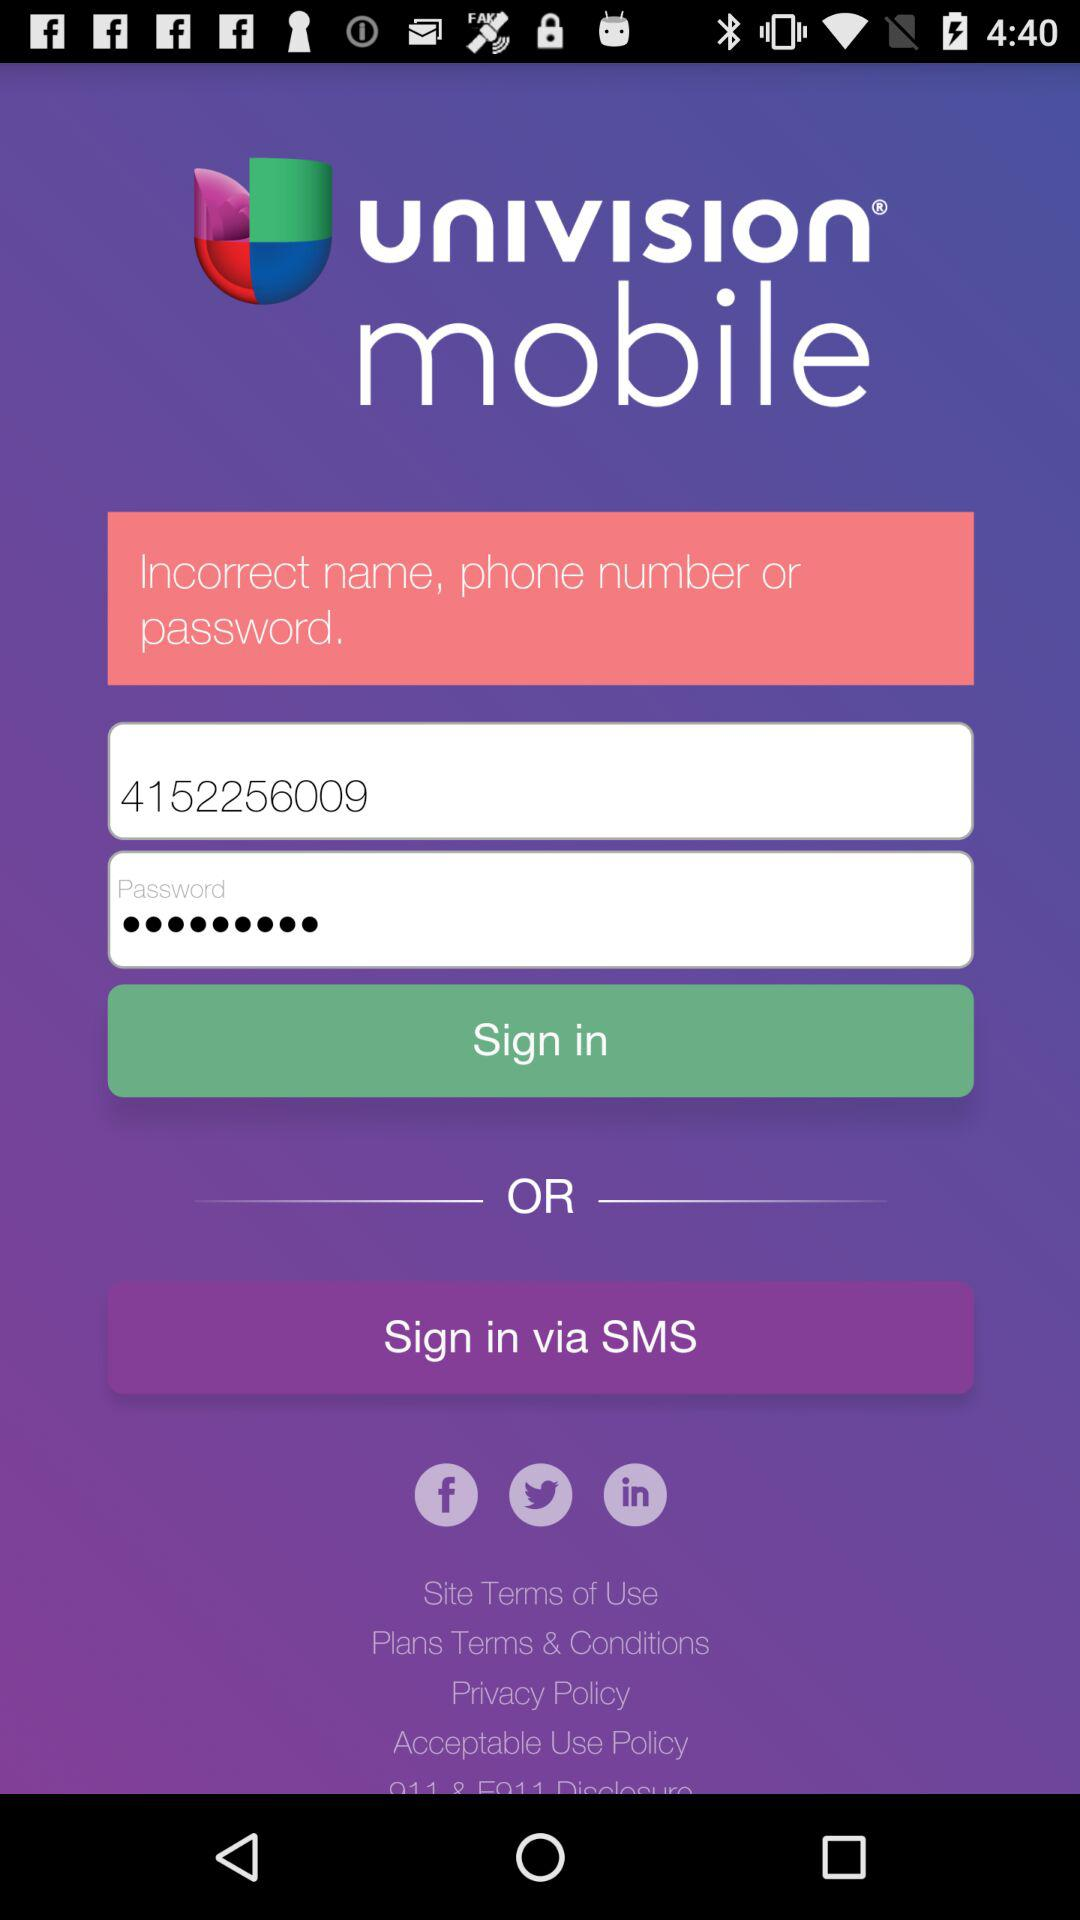How can we sign in?
When the provided information is insufficient, respond with <no answer>. <no answer> 